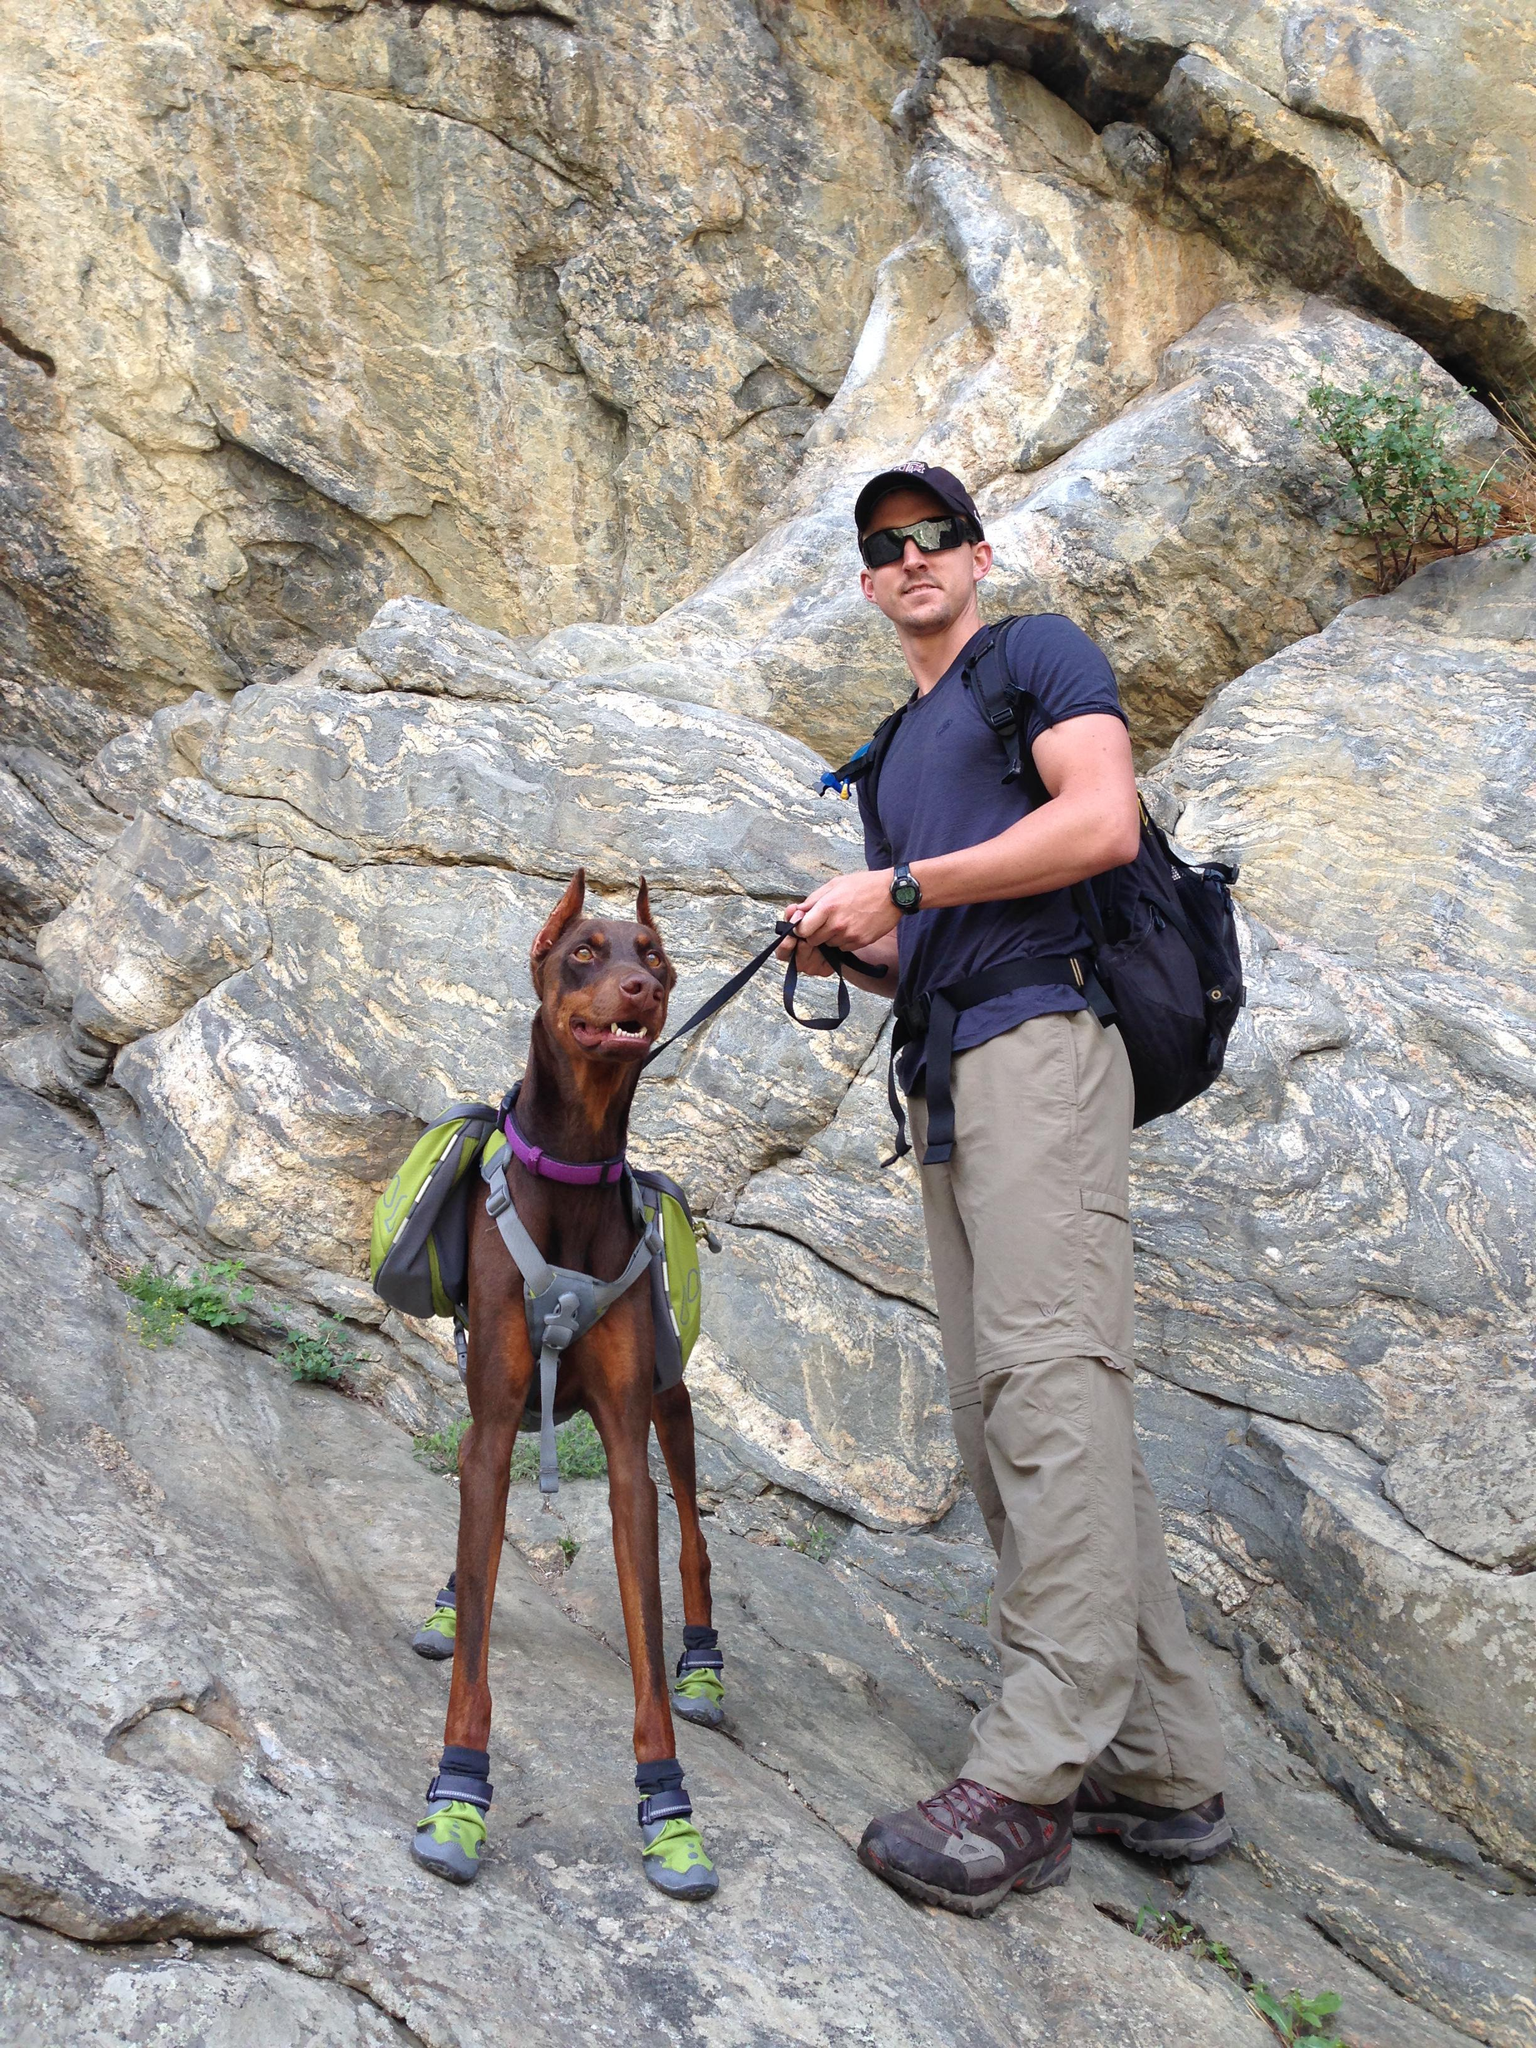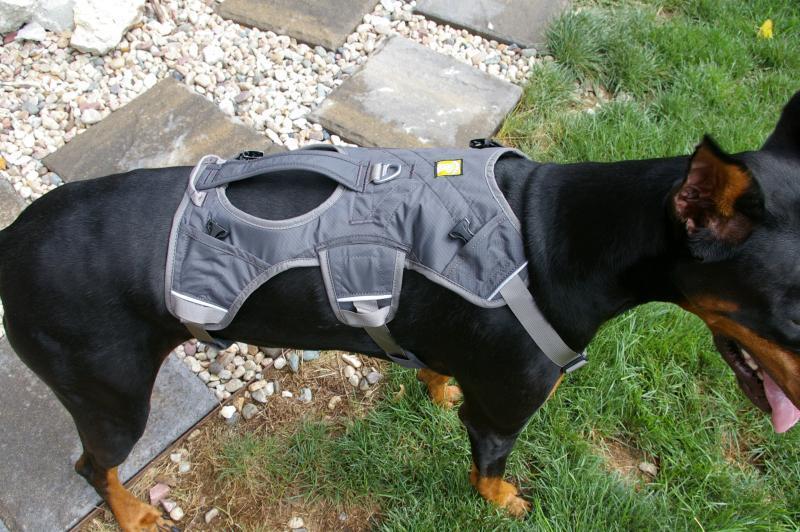The first image is the image on the left, the second image is the image on the right. Assess this claim about the two images: "A man with a backpack is standing with a dog in the image on the left.". Correct or not? Answer yes or no. Yes. 